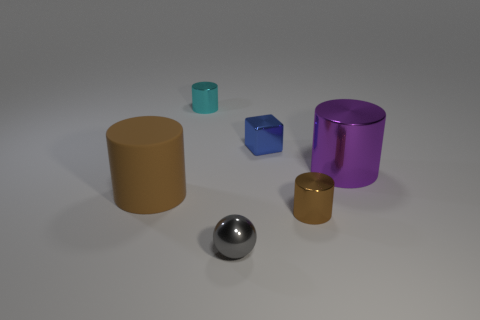What number of spheres are either small gray objects or tiny brown objects?
Make the answer very short. 1. What material is the cylinder to the right of the tiny brown cylinder?
Make the answer very short. Metal. The other cylinder that is the same color as the matte cylinder is what size?
Your answer should be very brief. Small. Is the color of the small cylinder to the left of the tiny sphere the same as the big cylinder on the left side of the tiny gray thing?
Provide a succinct answer. No. What number of things are either spheres or gray matte blocks?
Provide a succinct answer. 1. What number of other things are there of the same shape as the purple thing?
Provide a succinct answer. 3. Is the material of the tiny cylinder in front of the purple object the same as the large brown thing that is left of the purple object?
Ensure brevity in your answer.  No. There is a object that is both on the left side of the tiny shiny ball and to the right of the brown matte cylinder; what is its shape?
Offer a very short reply. Cylinder. Are there any other things that are made of the same material as the cyan cylinder?
Provide a succinct answer. Yes. There is a cylinder that is both in front of the large purple metal object and on the right side of the rubber thing; what material is it?
Give a very brief answer. Metal. 